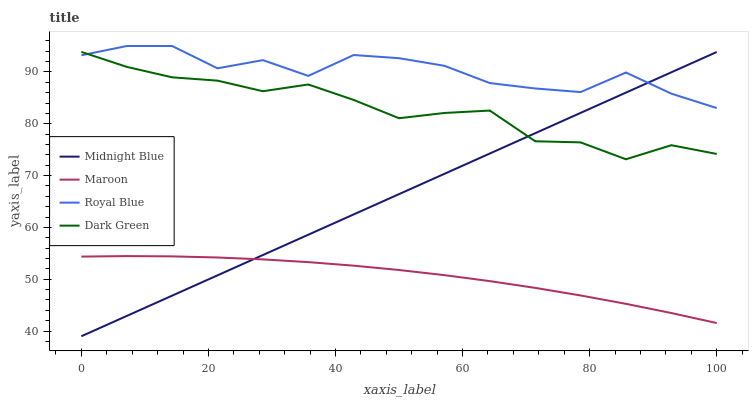Does Maroon have the minimum area under the curve?
Answer yes or no. Yes. Does Royal Blue have the maximum area under the curve?
Answer yes or no. Yes. Does Midnight Blue have the minimum area under the curve?
Answer yes or no. No. Does Midnight Blue have the maximum area under the curve?
Answer yes or no. No. Is Midnight Blue the smoothest?
Answer yes or no. Yes. Is Royal Blue the roughest?
Answer yes or no. Yes. Is Maroon the smoothest?
Answer yes or no. No. Is Maroon the roughest?
Answer yes or no. No. Does Midnight Blue have the lowest value?
Answer yes or no. Yes. Does Maroon have the lowest value?
Answer yes or no. No. Does Royal Blue have the highest value?
Answer yes or no. Yes. Does Midnight Blue have the highest value?
Answer yes or no. No. Is Maroon less than Dark Green?
Answer yes or no. Yes. Is Dark Green greater than Maroon?
Answer yes or no. Yes. Does Midnight Blue intersect Royal Blue?
Answer yes or no. Yes. Is Midnight Blue less than Royal Blue?
Answer yes or no. No. Is Midnight Blue greater than Royal Blue?
Answer yes or no. No. Does Maroon intersect Dark Green?
Answer yes or no. No. 